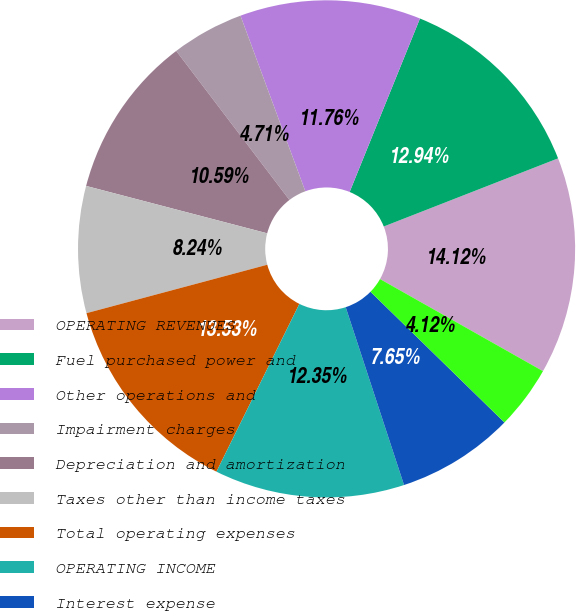Convert chart to OTSL. <chart><loc_0><loc_0><loc_500><loc_500><pie_chart><fcel>OPERATING REVENUES<fcel>Fuel purchased power and<fcel>Other operations and<fcel>Impairment charges<fcel>Depreciation and amortization<fcel>Taxes other than income taxes<fcel>Total operating expenses<fcel>OPERATING INCOME<fcel>Interest expense<fcel>Benefits associated with<nl><fcel>14.12%<fcel>12.94%<fcel>11.76%<fcel>4.71%<fcel>10.59%<fcel>8.24%<fcel>13.53%<fcel>12.35%<fcel>7.65%<fcel>4.12%<nl></chart> 